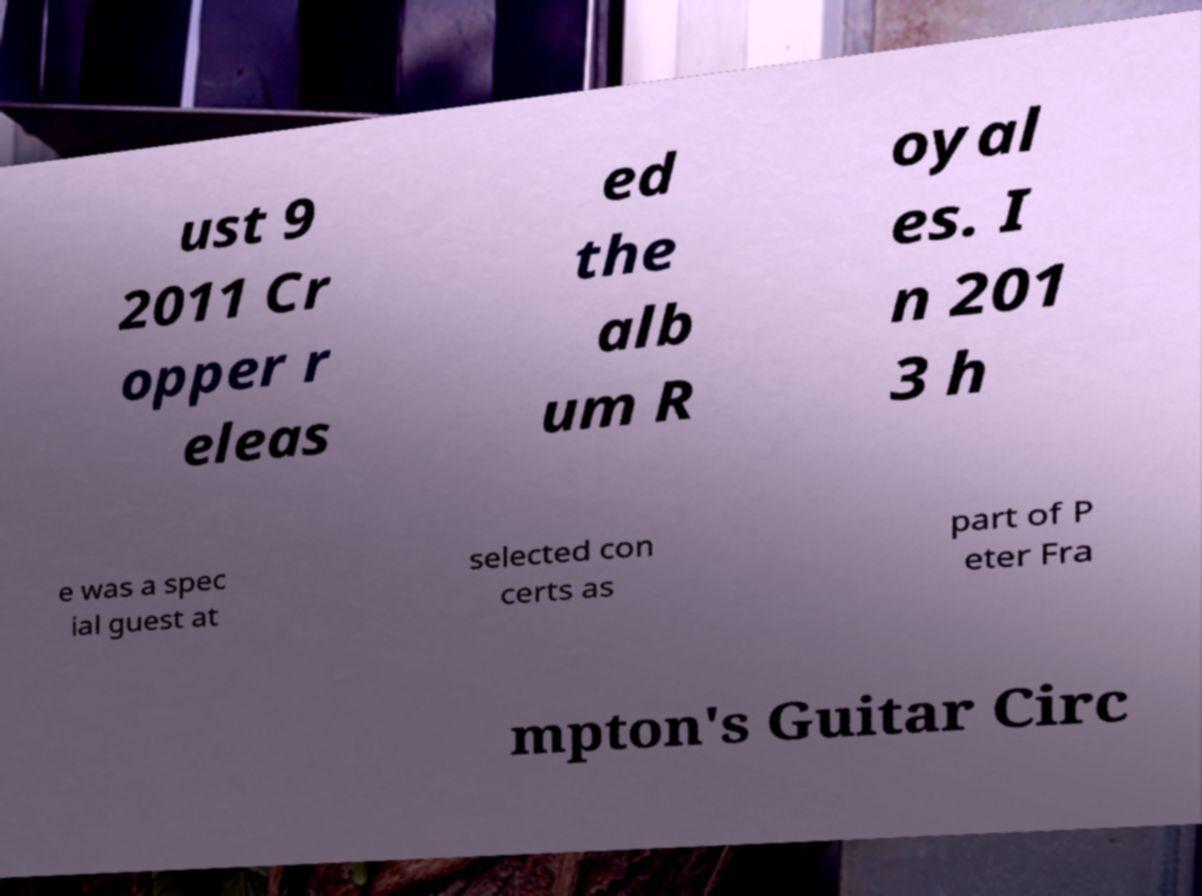Please read and relay the text visible in this image. What does it say? ust 9 2011 Cr opper r eleas ed the alb um R oyal es. I n 201 3 h e was a spec ial guest at selected con certs as part of P eter Fra mpton's Guitar Circ 